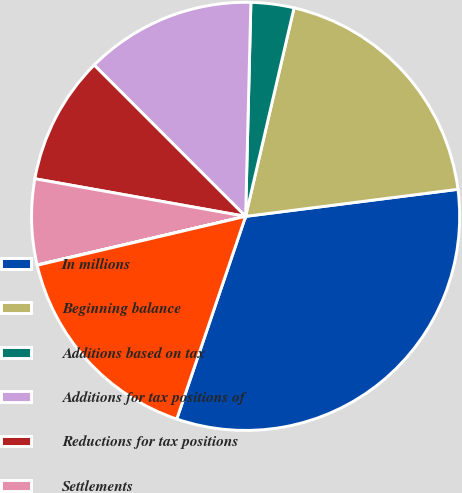Convert chart. <chart><loc_0><loc_0><loc_500><loc_500><pie_chart><fcel>In millions<fcel>Beginning balance<fcel>Additions based on tax<fcel>Additions for tax positions of<fcel>Reductions for tax positions<fcel>Settlements<fcel>Foreign currency translation<fcel>Ending balance<nl><fcel>32.23%<fcel>19.35%<fcel>3.24%<fcel>12.9%<fcel>9.68%<fcel>6.46%<fcel>0.02%<fcel>16.12%<nl></chart> 